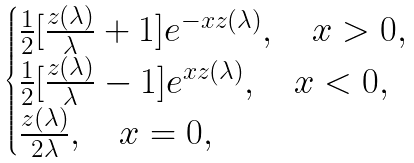<formula> <loc_0><loc_0><loc_500><loc_500>\begin{cases} \frac { 1 } { 2 } [ \frac { z ( \lambda ) } { \lambda } + 1 ] e ^ { - x z ( \lambda ) } , \quad x > 0 , \\ \frac { 1 } { 2 } [ \frac { z ( \lambda ) } { \lambda } - 1 ] e ^ { x z ( \lambda ) } , \quad x < 0 , \\ \frac { z ( \lambda ) } { 2 \lambda } , \quad x = 0 , \end{cases}</formula> 